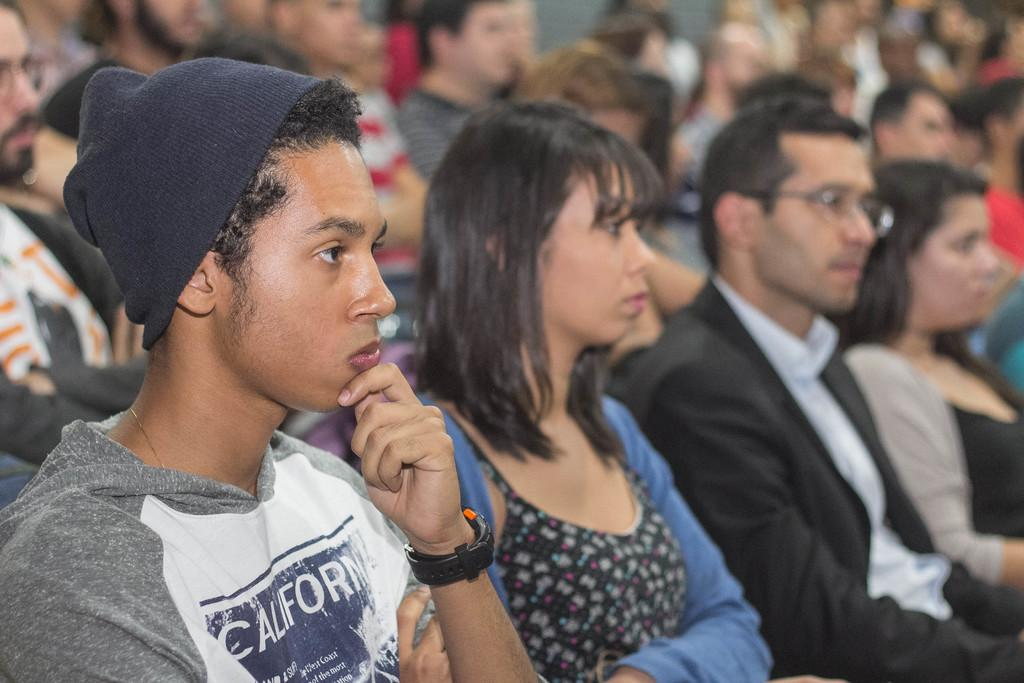What is the main subject of the image? The main subject of the image is a group of people. What are the people in the image doing? The people are looking to the right side. What type of wash is being performed by the people in the image? There is no indication of any wash being performed in the image; the people are simply looking to the right side. 